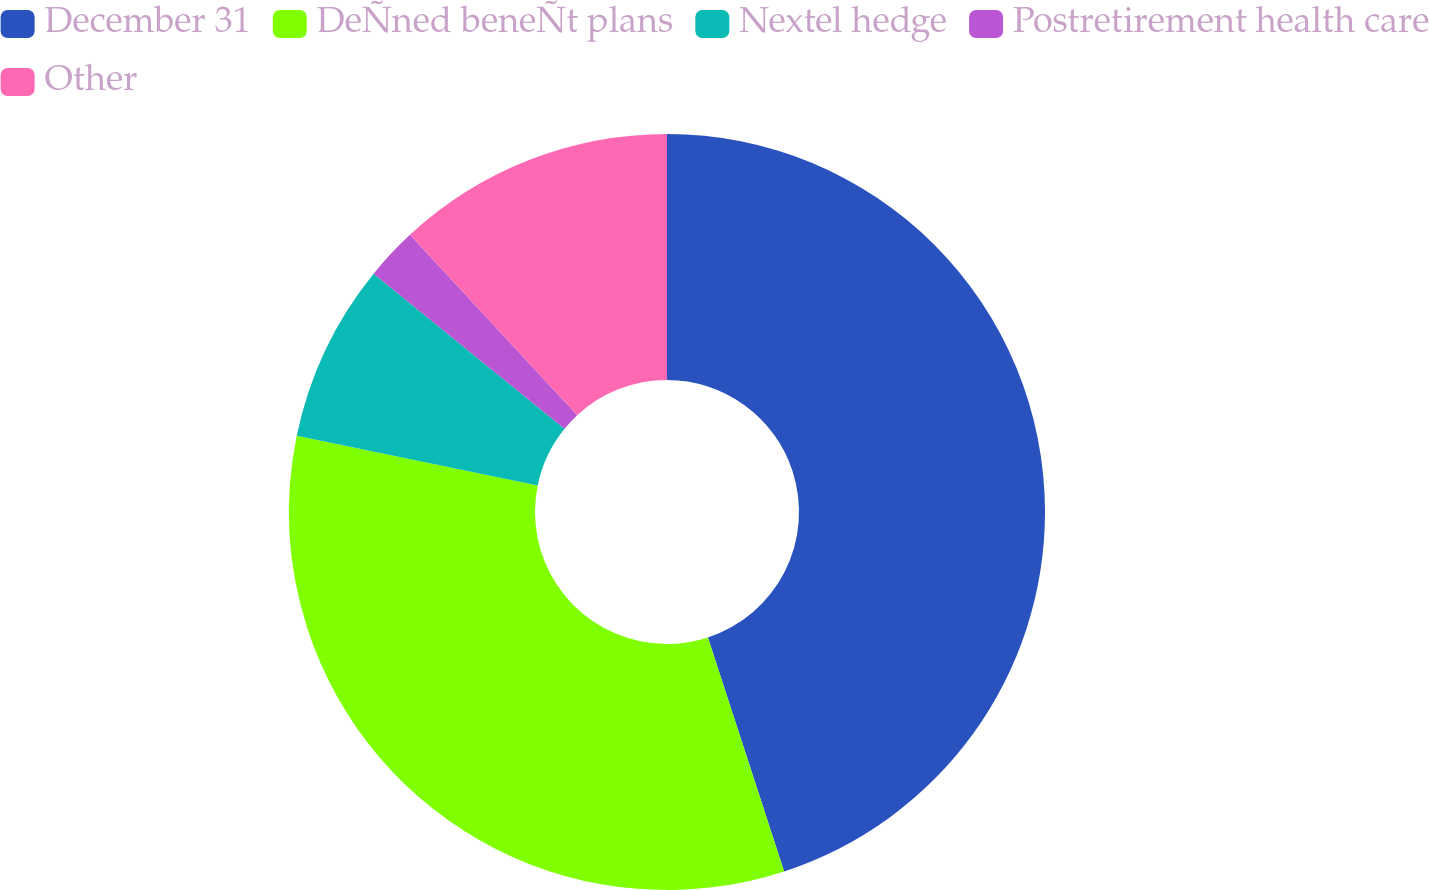Convert chart. <chart><loc_0><loc_0><loc_500><loc_500><pie_chart><fcel>December 31<fcel>DeÑned beneÑt plans<fcel>Nextel hedge<fcel>Postretirement health care<fcel>Other<nl><fcel>44.98%<fcel>33.24%<fcel>7.63%<fcel>2.24%<fcel>11.9%<nl></chart> 